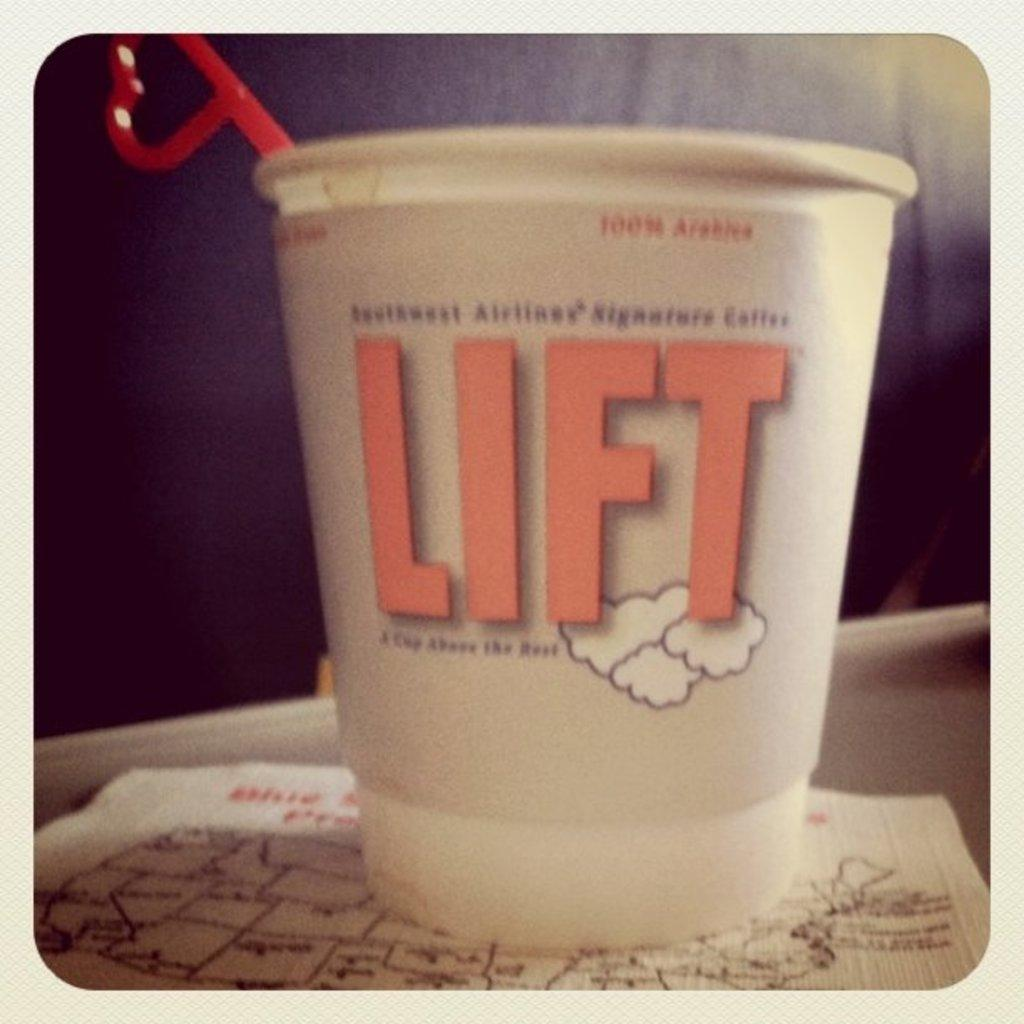What is inside the small glass in the image? The glass contains a scoop. What is the glass placed on in the image? The glass is placed on a paper. Where are the glass and paper located in the image? The glass and paper are on a countertop. Reasoning: Let's think step by following the guidelines to produce the conversation. We start by identifying the main subject in the image, which is the small glass. Then, we describe the contents of the glass and the object it is placed on. Finally, we mention the location of the glass and paper in the image. Each question is designed to elicit a specific detail about the image that is known from the provided facts. Absurd Question/Answer: What decisions is the committee making about the scoop in the image? There is no committee present in the image, and therefore no decisions are being made about the scoop. 